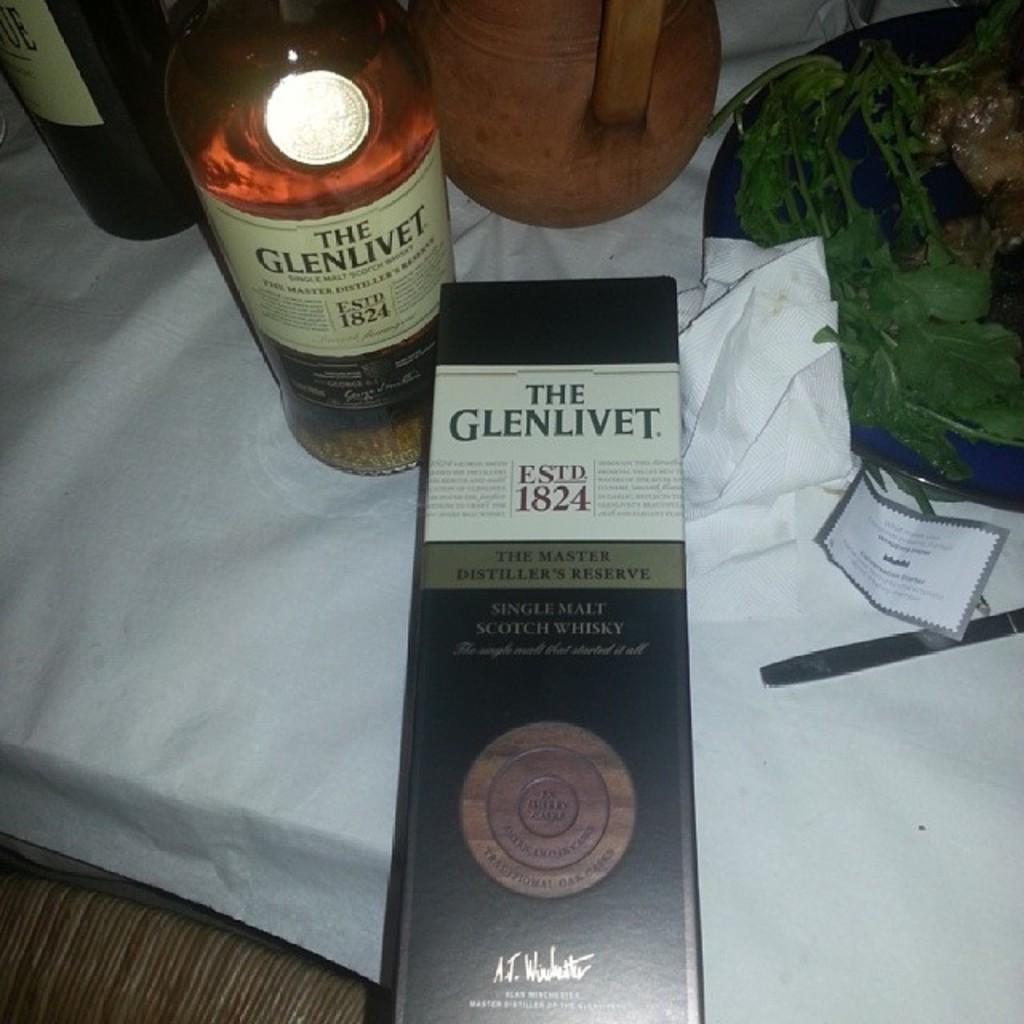<image>
Give a short and clear explanation of the subsequent image. A black box for the Glenlivet next to the container of it. 